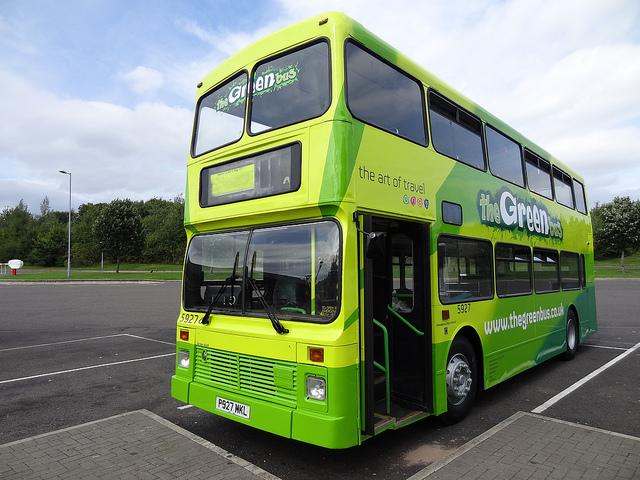What the bus number of the green bus?
Concise answer only. 5927. What is the phone number on the green bus?
Give a very brief answer. Cannot see phone number. Is the bus empty or full?
Keep it brief. Empty. Where is the umbrella?
Short answer required. Inside. What does Green bus mean?
Quick response, please. Colorful. What color is the bus?
Give a very brief answer. Green. 